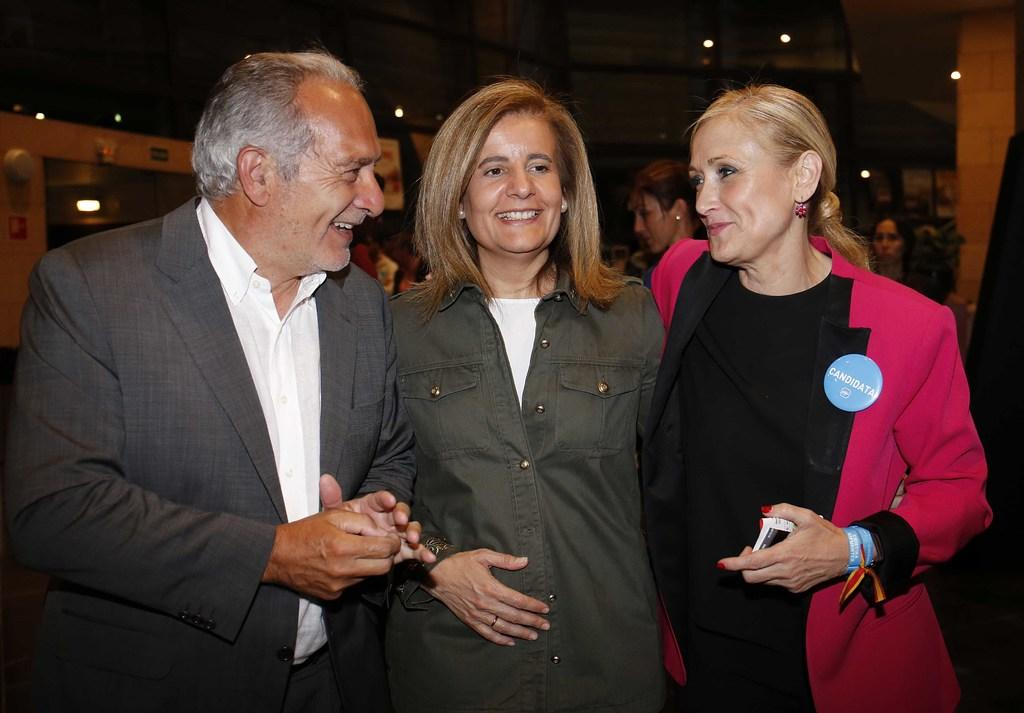What is happening in the foreground of the image? There are people standing in the foreground of the image. Can you describe the people in the background of the image? There are other people standing at the back of the image. What can be inferred about the lighting conditions in the image? The background of the image appears to be dark. What type of riddle is being solved by the people in the image? There is no riddle being solved in the image; it simply shows people standing in the foreground and background. Can you tell me how many fans are visible in the image? There are no fans present in the image. 